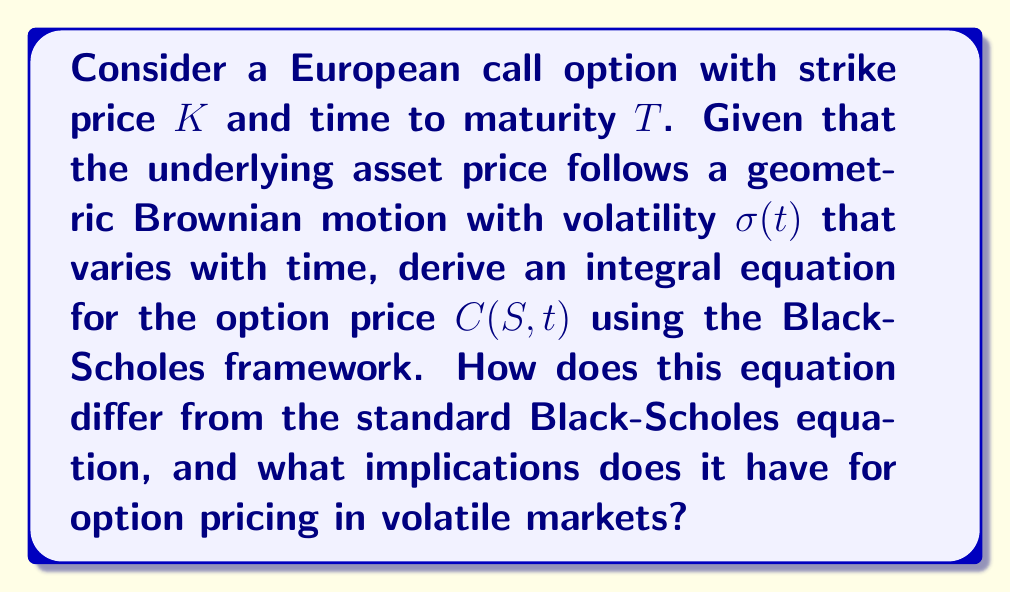Provide a solution to this math problem. To solve this problem, we'll follow these steps:

1) Recall the standard Black-Scholes partial differential equation (PDE):

   $$\frac{\partial C}{\partial t} + \frac{1}{2}\sigma^2S^2\frac{\partial^2 C}{\partial S^2} + rS\frac{\partial C}{\partial S} - rC = 0$$

2) In our case, volatility $\sigma$ is a function of time. Let's denote it as $\sigma(t)$. The modified PDE becomes:

   $$\frac{\partial C}{\partial t} + \frac{1}{2}\sigma^2(t)S^2\frac{\partial^2 C}{\partial S^2} + rS\frac{\partial C}{\partial S} - rC = 0$$

3) To convert this PDE into an integral equation, we use Green's function method. The Green's function for the Black-Scholes equation is:

   $$G(S,t;S',T) = \frac{1}{S'\sqrt{2\pi(T-t)\int_t^T \sigma^2(u)du}} \exp\left(-\frac{(\ln(S/S') + (r-\frac{1}{2}\int_t^T \sigma^2(u)du)(T-t))^2}{2(T-t)\int_t^T \sigma^2(u)du}\right)$$

4) The integral equation for the option price is:

   $$C(S,t) = e^{-r(T-t)}\int_0^\infty \max(S'-K,0)G(S,t;S',T)dS'$$

5) Substituting the Green's function:

   $$C(S,t) = e^{-r(T-t)}\int_K^\infty (S'-K)\frac{1}{S'\sqrt{2\pi(T-t)\int_t^T \sigma^2(u)du}} \exp\left(-\frac{(\ln(S/S') + (r-\frac{1}{2}\int_t^T \sigma^2(u)du)(T-t))^2}{2(T-t)\int_t^T \sigma^2(u)du}\right)dS'$$

This integral equation differs from the standard Black-Scholes formula in that it incorporates time-varying volatility. The implications for option pricing in volatile markets are:

1) The option price now depends on the entire path of volatility from $t$ to $T$, not just a single volatility value.
2) Higher overall volatility generally leads to higher option prices.
3) The shape of the volatility curve can significantly impact option prices, especially for longer-term options.
4) This model can capture market expectations of future volatility changes, making it more responsive to market conditions.
Answer: $C(S,t) = e^{-r(T-t)}\int_K^\infty (S'-K)\frac{1}{S'\sqrt{2\pi(T-t)\int_t^T \sigma^2(u)du}} \exp\left(-\frac{(\ln(S/S') + (r-\frac{1}{2}\int_t^T \sigma^2(u)du)(T-t))^2}{2(T-t)\int_t^T \sigma^2(u)du}\right)dS'$ 